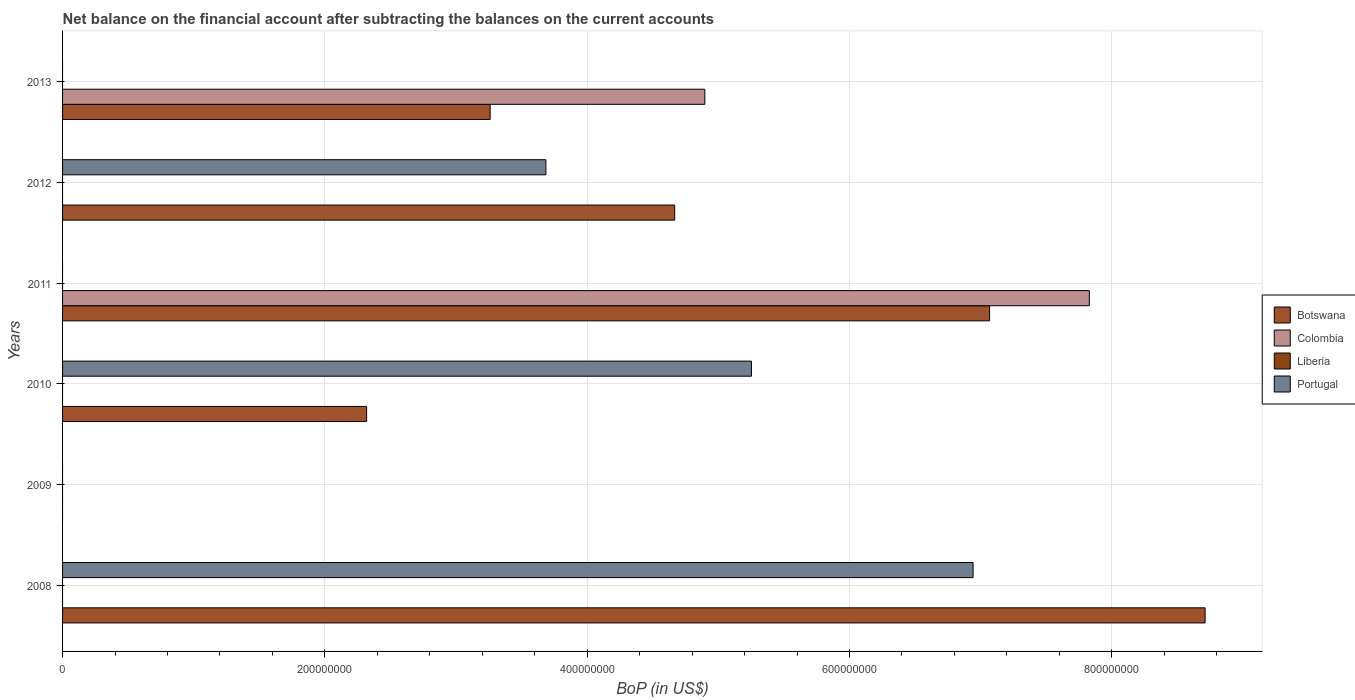How many bars are there on the 5th tick from the bottom?
Offer a terse response. 2. In how many cases, is the number of bars for a given year not equal to the number of legend labels?
Your response must be concise. 6. What is the Balance of Payments in Liberia in 2013?
Provide a short and direct response. 0. Across all years, what is the maximum Balance of Payments in Portugal?
Give a very brief answer. 6.94e+08. Across all years, what is the minimum Balance of Payments in Portugal?
Your answer should be very brief. 0. What is the total Balance of Payments in Botswana in the graph?
Provide a succinct answer. 2.60e+09. What is the difference between the Balance of Payments in Botswana in 2008 and that in 2011?
Provide a short and direct response. 1.64e+08. What is the difference between the Balance of Payments in Botswana in 2010 and the Balance of Payments in Colombia in 2012?
Make the answer very short. 2.32e+08. What is the average Balance of Payments in Botswana per year?
Offer a very short reply. 4.34e+08. In the year 2008, what is the difference between the Balance of Payments in Botswana and Balance of Payments in Portugal?
Your answer should be compact. 1.77e+08. What is the ratio of the Balance of Payments in Botswana in 2008 to that in 2013?
Offer a terse response. 2.67. What is the difference between the highest and the second highest Balance of Payments in Botswana?
Provide a short and direct response. 1.64e+08. What is the difference between the highest and the lowest Balance of Payments in Colombia?
Offer a very short reply. 7.83e+08. In how many years, is the Balance of Payments in Portugal greater than the average Balance of Payments in Portugal taken over all years?
Keep it short and to the point. 3. Is it the case that in every year, the sum of the Balance of Payments in Colombia and Balance of Payments in Portugal is greater than the Balance of Payments in Botswana?
Give a very brief answer. No. How many bars are there?
Your answer should be compact. 10. Are all the bars in the graph horizontal?
Your response must be concise. Yes. What is the difference between two consecutive major ticks on the X-axis?
Keep it short and to the point. 2.00e+08. Does the graph contain grids?
Make the answer very short. Yes. Where does the legend appear in the graph?
Ensure brevity in your answer.  Center right. How many legend labels are there?
Offer a terse response. 4. How are the legend labels stacked?
Your answer should be compact. Vertical. What is the title of the graph?
Provide a short and direct response. Net balance on the financial account after subtracting the balances on the current accounts. What is the label or title of the X-axis?
Give a very brief answer. BoP (in US$). What is the label or title of the Y-axis?
Make the answer very short. Years. What is the BoP (in US$) in Botswana in 2008?
Ensure brevity in your answer.  8.71e+08. What is the BoP (in US$) in Colombia in 2008?
Offer a very short reply. 0. What is the BoP (in US$) in Portugal in 2008?
Make the answer very short. 6.94e+08. What is the BoP (in US$) of Botswana in 2009?
Make the answer very short. 0. What is the BoP (in US$) of Liberia in 2009?
Your response must be concise. 0. What is the BoP (in US$) of Portugal in 2009?
Provide a succinct answer. 0. What is the BoP (in US$) of Botswana in 2010?
Offer a terse response. 2.32e+08. What is the BoP (in US$) in Liberia in 2010?
Offer a terse response. 0. What is the BoP (in US$) of Portugal in 2010?
Provide a short and direct response. 5.25e+08. What is the BoP (in US$) of Botswana in 2011?
Ensure brevity in your answer.  7.07e+08. What is the BoP (in US$) in Colombia in 2011?
Your answer should be very brief. 7.83e+08. What is the BoP (in US$) in Liberia in 2011?
Provide a succinct answer. 0. What is the BoP (in US$) in Botswana in 2012?
Keep it short and to the point. 4.67e+08. What is the BoP (in US$) of Colombia in 2012?
Your response must be concise. 0. What is the BoP (in US$) in Liberia in 2012?
Provide a short and direct response. 0. What is the BoP (in US$) of Portugal in 2012?
Your answer should be compact. 3.69e+08. What is the BoP (in US$) of Botswana in 2013?
Ensure brevity in your answer.  3.26e+08. What is the BoP (in US$) in Colombia in 2013?
Keep it short and to the point. 4.90e+08. What is the BoP (in US$) of Liberia in 2013?
Your answer should be very brief. 0. Across all years, what is the maximum BoP (in US$) of Botswana?
Your response must be concise. 8.71e+08. Across all years, what is the maximum BoP (in US$) in Colombia?
Ensure brevity in your answer.  7.83e+08. Across all years, what is the maximum BoP (in US$) of Portugal?
Provide a short and direct response. 6.94e+08. Across all years, what is the minimum BoP (in US$) in Colombia?
Provide a succinct answer. 0. What is the total BoP (in US$) in Botswana in the graph?
Offer a terse response. 2.60e+09. What is the total BoP (in US$) in Colombia in the graph?
Make the answer very short. 1.27e+09. What is the total BoP (in US$) of Portugal in the graph?
Offer a very short reply. 1.59e+09. What is the difference between the BoP (in US$) in Botswana in 2008 and that in 2010?
Your answer should be compact. 6.39e+08. What is the difference between the BoP (in US$) in Portugal in 2008 and that in 2010?
Give a very brief answer. 1.69e+08. What is the difference between the BoP (in US$) of Botswana in 2008 and that in 2011?
Keep it short and to the point. 1.64e+08. What is the difference between the BoP (in US$) of Botswana in 2008 and that in 2012?
Your answer should be compact. 4.04e+08. What is the difference between the BoP (in US$) of Portugal in 2008 and that in 2012?
Your answer should be compact. 3.26e+08. What is the difference between the BoP (in US$) in Botswana in 2008 and that in 2013?
Your response must be concise. 5.45e+08. What is the difference between the BoP (in US$) in Botswana in 2010 and that in 2011?
Keep it short and to the point. -4.75e+08. What is the difference between the BoP (in US$) in Botswana in 2010 and that in 2012?
Make the answer very short. -2.35e+08. What is the difference between the BoP (in US$) of Portugal in 2010 and that in 2012?
Your answer should be very brief. 1.57e+08. What is the difference between the BoP (in US$) in Botswana in 2010 and that in 2013?
Provide a short and direct response. -9.42e+07. What is the difference between the BoP (in US$) of Botswana in 2011 and that in 2012?
Give a very brief answer. 2.40e+08. What is the difference between the BoP (in US$) in Botswana in 2011 and that in 2013?
Your answer should be compact. 3.81e+08. What is the difference between the BoP (in US$) in Colombia in 2011 and that in 2013?
Give a very brief answer. 2.93e+08. What is the difference between the BoP (in US$) of Botswana in 2012 and that in 2013?
Keep it short and to the point. 1.41e+08. What is the difference between the BoP (in US$) in Botswana in 2008 and the BoP (in US$) in Portugal in 2010?
Offer a terse response. 3.46e+08. What is the difference between the BoP (in US$) of Botswana in 2008 and the BoP (in US$) of Colombia in 2011?
Ensure brevity in your answer.  8.83e+07. What is the difference between the BoP (in US$) in Botswana in 2008 and the BoP (in US$) in Portugal in 2012?
Your response must be concise. 5.03e+08. What is the difference between the BoP (in US$) of Botswana in 2008 and the BoP (in US$) of Colombia in 2013?
Ensure brevity in your answer.  3.81e+08. What is the difference between the BoP (in US$) in Botswana in 2010 and the BoP (in US$) in Colombia in 2011?
Your answer should be compact. -5.51e+08. What is the difference between the BoP (in US$) in Botswana in 2010 and the BoP (in US$) in Portugal in 2012?
Offer a very short reply. -1.37e+08. What is the difference between the BoP (in US$) of Botswana in 2010 and the BoP (in US$) of Colombia in 2013?
Ensure brevity in your answer.  -2.58e+08. What is the difference between the BoP (in US$) of Botswana in 2011 and the BoP (in US$) of Portugal in 2012?
Make the answer very short. 3.38e+08. What is the difference between the BoP (in US$) of Colombia in 2011 and the BoP (in US$) of Portugal in 2012?
Make the answer very short. 4.14e+08. What is the difference between the BoP (in US$) in Botswana in 2011 and the BoP (in US$) in Colombia in 2013?
Keep it short and to the point. 2.17e+08. What is the difference between the BoP (in US$) of Botswana in 2012 and the BoP (in US$) of Colombia in 2013?
Ensure brevity in your answer.  -2.30e+07. What is the average BoP (in US$) of Botswana per year?
Make the answer very short. 4.34e+08. What is the average BoP (in US$) of Colombia per year?
Keep it short and to the point. 2.12e+08. What is the average BoP (in US$) of Portugal per year?
Give a very brief answer. 2.65e+08. In the year 2008, what is the difference between the BoP (in US$) in Botswana and BoP (in US$) in Portugal?
Your answer should be compact. 1.77e+08. In the year 2010, what is the difference between the BoP (in US$) of Botswana and BoP (in US$) of Portugal?
Ensure brevity in your answer.  -2.93e+08. In the year 2011, what is the difference between the BoP (in US$) of Botswana and BoP (in US$) of Colombia?
Ensure brevity in your answer.  -7.60e+07. In the year 2012, what is the difference between the BoP (in US$) in Botswana and BoP (in US$) in Portugal?
Give a very brief answer. 9.82e+07. In the year 2013, what is the difference between the BoP (in US$) of Botswana and BoP (in US$) of Colombia?
Keep it short and to the point. -1.64e+08. What is the ratio of the BoP (in US$) of Botswana in 2008 to that in 2010?
Your answer should be compact. 3.76. What is the ratio of the BoP (in US$) of Portugal in 2008 to that in 2010?
Keep it short and to the point. 1.32. What is the ratio of the BoP (in US$) of Botswana in 2008 to that in 2011?
Offer a terse response. 1.23. What is the ratio of the BoP (in US$) of Botswana in 2008 to that in 2012?
Your answer should be very brief. 1.87. What is the ratio of the BoP (in US$) of Portugal in 2008 to that in 2012?
Ensure brevity in your answer.  1.88. What is the ratio of the BoP (in US$) of Botswana in 2008 to that in 2013?
Provide a succinct answer. 2.67. What is the ratio of the BoP (in US$) in Botswana in 2010 to that in 2011?
Offer a very short reply. 0.33. What is the ratio of the BoP (in US$) in Botswana in 2010 to that in 2012?
Provide a succinct answer. 0.5. What is the ratio of the BoP (in US$) of Portugal in 2010 to that in 2012?
Your answer should be very brief. 1.43. What is the ratio of the BoP (in US$) in Botswana in 2010 to that in 2013?
Offer a very short reply. 0.71. What is the ratio of the BoP (in US$) in Botswana in 2011 to that in 2012?
Offer a very short reply. 1.51. What is the ratio of the BoP (in US$) in Botswana in 2011 to that in 2013?
Make the answer very short. 2.17. What is the ratio of the BoP (in US$) in Colombia in 2011 to that in 2013?
Ensure brevity in your answer.  1.6. What is the ratio of the BoP (in US$) of Botswana in 2012 to that in 2013?
Give a very brief answer. 1.43. What is the difference between the highest and the second highest BoP (in US$) in Botswana?
Ensure brevity in your answer.  1.64e+08. What is the difference between the highest and the second highest BoP (in US$) of Portugal?
Provide a succinct answer. 1.69e+08. What is the difference between the highest and the lowest BoP (in US$) of Botswana?
Keep it short and to the point. 8.71e+08. What is the difference between the highest and the lowest BoP (in US$) of Colombia?
Make the answer very short. 7.83e+08. What is the difference between the highest and the lowest BoP (in US$) of Portugal?
Ensure brevity in your answer.  6.94e+08. 